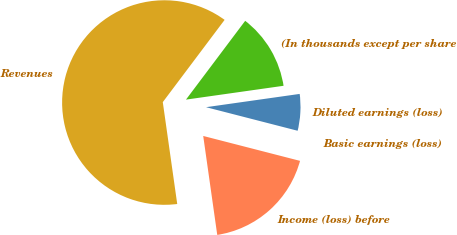Convert chart. <chart><loc_0><loc_0><loc_500><loc_500><pie_chart><fcel>(In thousands except per share<fcel>Revenues<fcel>Income (loss) before<fcel>Basic earnings (loss)<fcel>Diluted earnings (loss)<nl><fcel>12.5%<fcel>62.5%<fcel>18.75%<fcel>0.0%<fcel>6.25%<nl></chart> 